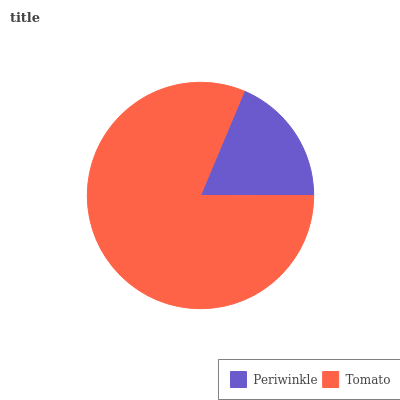Is Periwinkle the minimum?
Answer yes or no. Yes. Is Tomato the maximum?
Answer yes or no. Yes. Is Tomato the minimum?
Answer yes or no. No. Is Tomato greater than Periwinkle?
Answer yes or no. Yes. Is Periwinkle less than Tomato?
Answer yes or no. Yes. Is Periwinkle greater than Tomato?
Answer yes or no. No. Is Tomato less than Periwinkle?
Answer yes or no. No. Is Tomato the high median?
Answer yes or no. Yes. Is Periwinkle the low median?
Answer yes or no. Yes. Is Periwinkle the high median?
Answer yes or no. No. Is Tomato the low median?
Answer yes or no. No. 